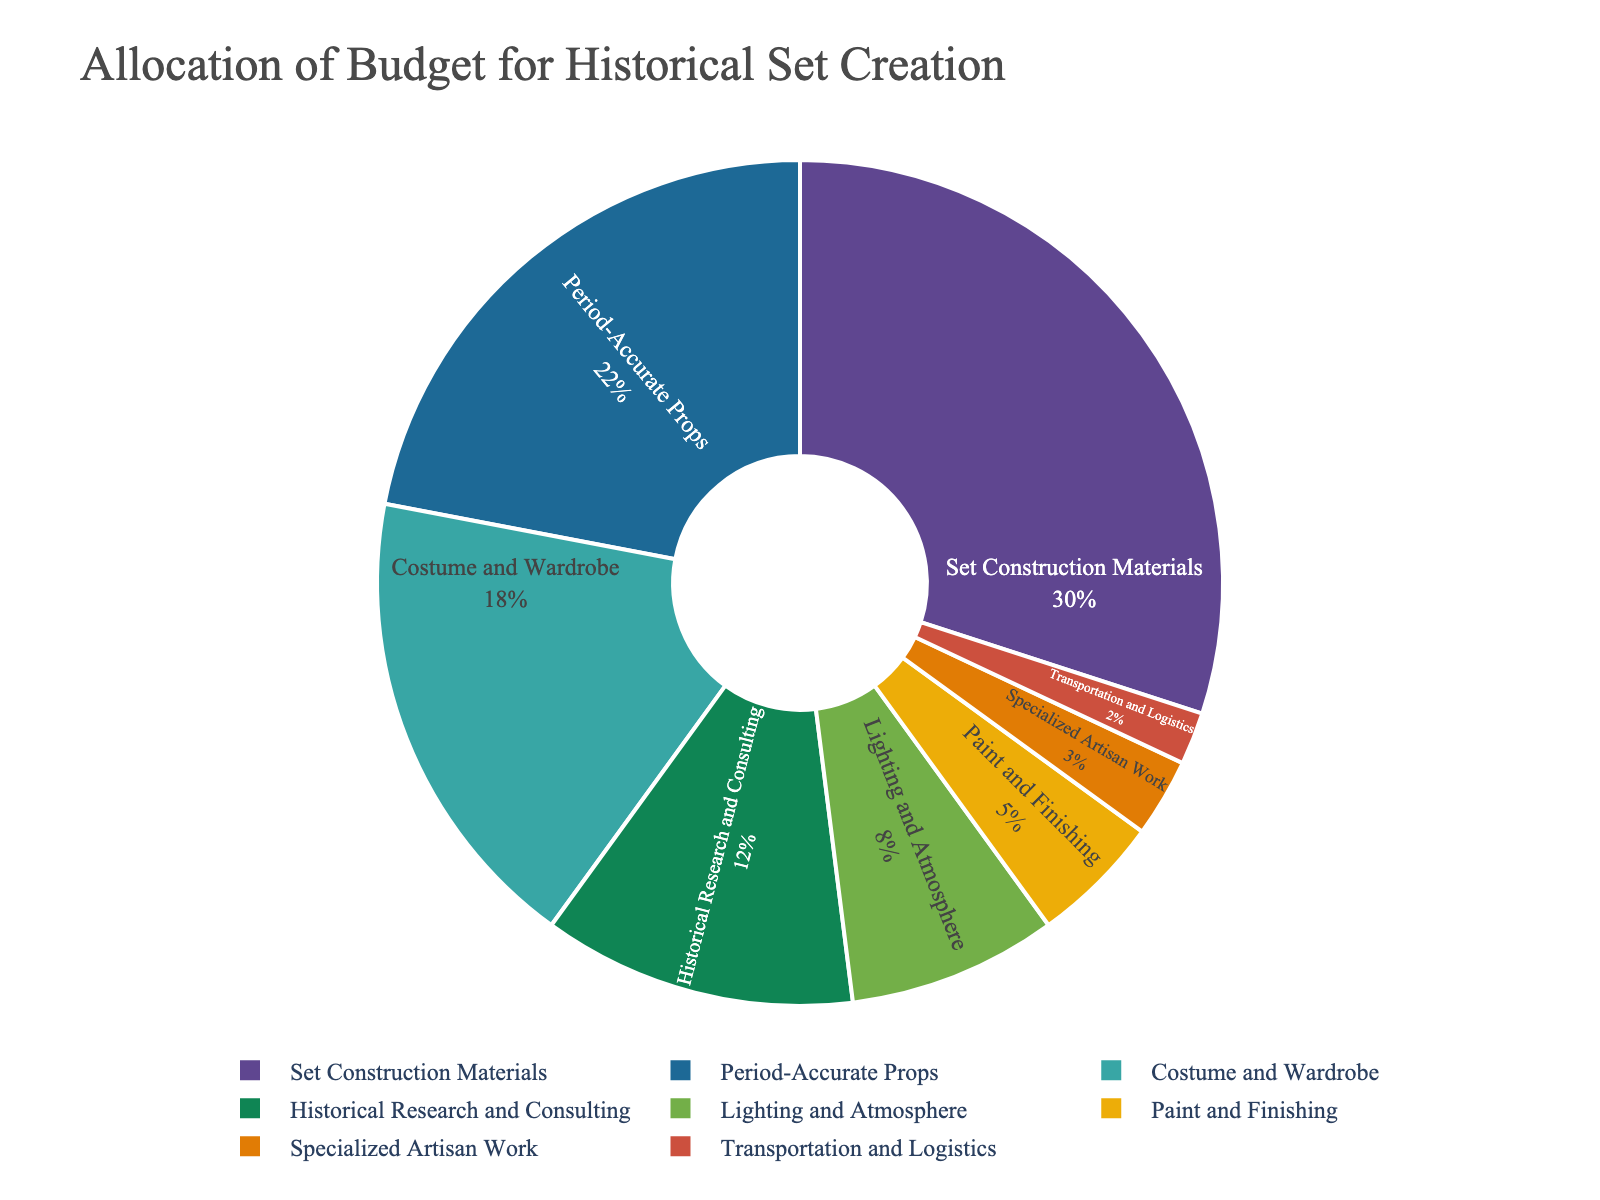What percentage of the budget is allocated to Set Construction Materials? The pie chart shows different budget categories, and by looking at the 'Set Construction Materials' segment, we see that it is labeled with its percentage value.
Answer: 30% Which category has a lower budget allocation, Lighting and Atmosphere or Paint and Finishing? By comparing the two segments in the pie chart, 'Lighting and Atmosphere' has 8% and 'Paint and Finishing' has 5%.
Answer: Paint and Finishing What is the combined percentage of the budget for Costume and Wardrobe and Historical Research and Consulting? Add the percentages of 'Costume and Wardrobe' (18%) and 'Historical Research and Consulting' (12%) by looking at each respective segment. 18% + 12% = 30%.
Answer: 30% Which category has the smallest budget allocation? By comparing all segments, 'Transportation and Logistics' has the smallest percentage.
Answer: Transportation and Logistics Is the budget for Period-Accurate Props greater than the sum of Paint and Finishing and Specialized Artisan Work? Compare 'Period-Accurate Props' (22%) with the sum of 'Paint and Finishing' (5%) and 'Specialized Artisan Work' (3%). 5% + 3% = 8% and 22% > 8%.
Answer: Yes What is the difference in budget allocation between Set Construction Materials and Costume and Wardrobe? Subtract 'Costume and Wardrobe' percentage (18%) from 'Set Construction Materials' percentage (30%). 30% - 18% = 12%.
Answer: 12% Between Set Construction Materials and Historical Research and Consulting, which category has a higher budget allocation and by how much? Compare the percentages: 'Set Construction Materials' (30%) and 'Historical Research and Consulting' (12%). Subtract the smaller from the larger. 30% - 12% = 18%.
Answer: Set Construction Materials by 18% How does the allocation for Historical Research and Consulting compare to Lighting and Atmosphere in terms of budget percentage? Compare 'Historical Research and Consulting' (12%) and 'Lighting and Atmosphere' (8%) based on their segments in the pie chart.
Answer: Historical Research and Consulting has a higher percentage What percentage of the budget is allocated to categories with percentages less than 10%? Add the percentages of 'Lighting and Atmosphere' (8%), 'Paint and Finishing' (5%), 'Specialized Artisan Work' (3%), and 'Transportation and Logistics' (2%). 8% + 5% + 3% + 2% = 18%.
Answer: 18% 